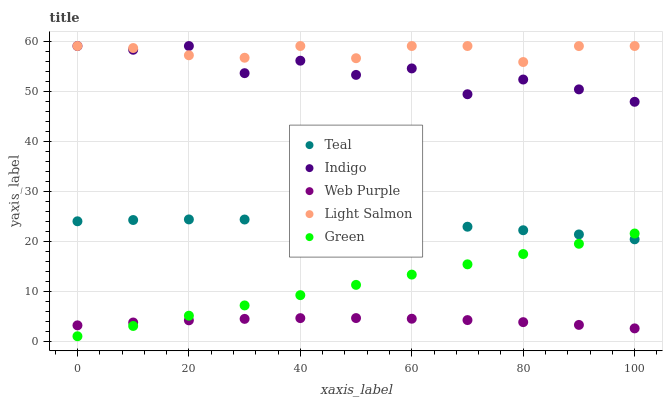Does Web Purple have the minimum area under the curve?
Answer yes or no. Yes. Does Light Salmon have the maximum area under the curve?
Answer yes or no. Yes. Does Indigo have the minimum area under the curve?
Answer yes or no. No. Does Indigo have the maximum area under the curve?
Answer yes or no. No. Is Green the smoothest?
Answer yes or no. Yes. Is Indigo the roughest?
Answer yes or no. Yes. Is Web Purple the smoothest?
Answer yes or no. No. Is Web Purple the roughest?
Answer yes or no. No. Does Green have the lowest value?
Answer yes or no. Yes. Does Web Purple have the lowest value?
Answer yes or no. No. Does Light Salmon have the highest value?
Answer yes or no. Yes. Does Web Purple have the highest value?
Answer yes or no. No. Is Green less than Indigo?
Answer yes or no. Yes. Is Indigo greater than Web Purple?
Answer yes or no. Yes. Does Green intersect Teal?
Answer yes or no. Yes. Is Green less than Teal?
Answer yes or no. No. Is Green greater than Teal?
Answer yes or no. No. Does Green intersect Indigo?
Answer yes or no. No. 